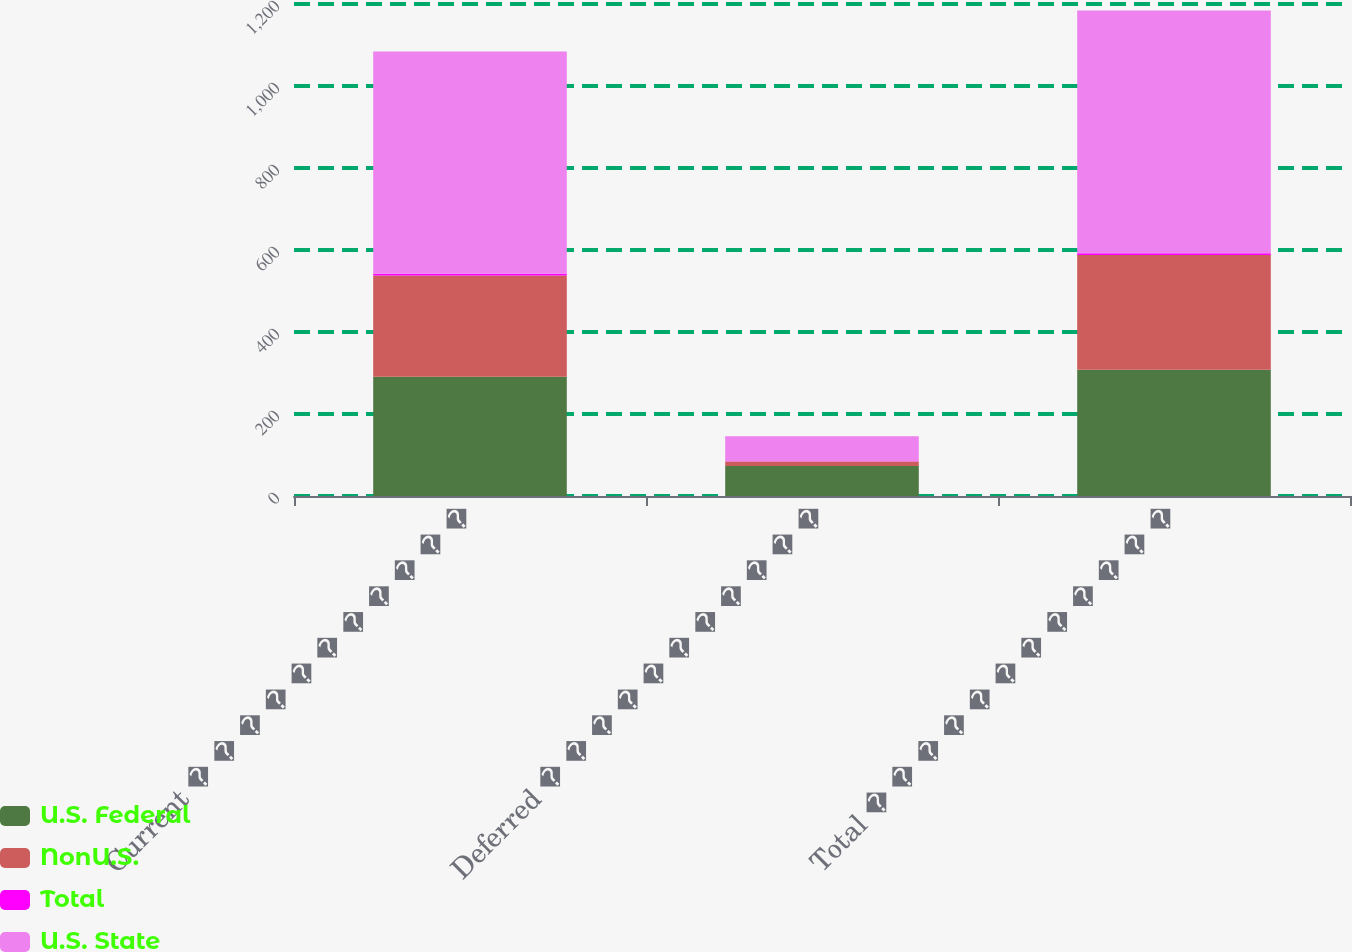Convert chart. <chart><loc_0><loc_0><loc_500><loc_500><stacked_bar_chart><ecel><fcel>Current � � � � � � � � � � �<fcel>Deferred � � � � � � � � � � �<fcel>Total � � � � � � � � � � � �<nl><fcel>U.S. Federal<fcel>291<fcel>73<fcel>308<nl><fcel>NonU.S.<fcel>247<fcel>11<fcel>280<nl><fcel>Total<fcel>4<fcel>1<fcel>4<nl><fcel>U.S. State<fcel>542<fcel>61<fcel>592<nl></chart> 